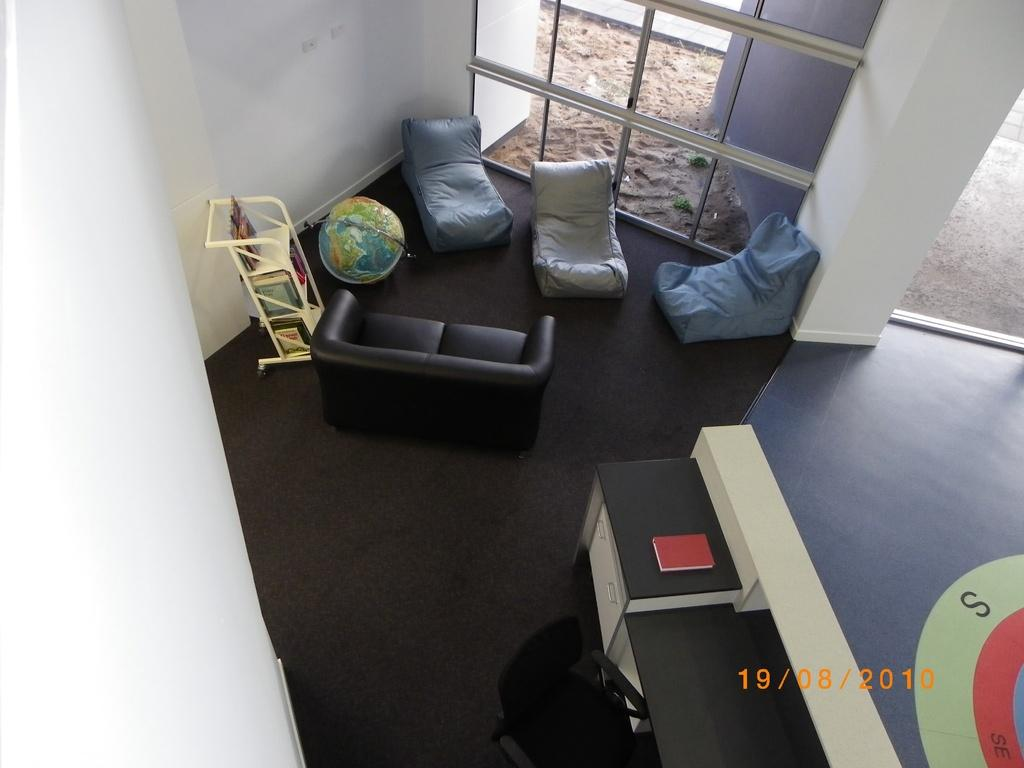What type of space is shown in the image? The image depicts the interior of a room. What type of furniture can be seen in the room? There are sofas, a stand, and a chair in the room. Is there any reading material present in the image? Yes, there is a book on a table in the room. What can be seen on the walls of the room? The walls are visible in the room. What type of jewel is placed on the chair in the image? There is no jewel present on the chair in the image. What type of jar can be seen on the stand in the image? There is no jar present on the stand in the image. 